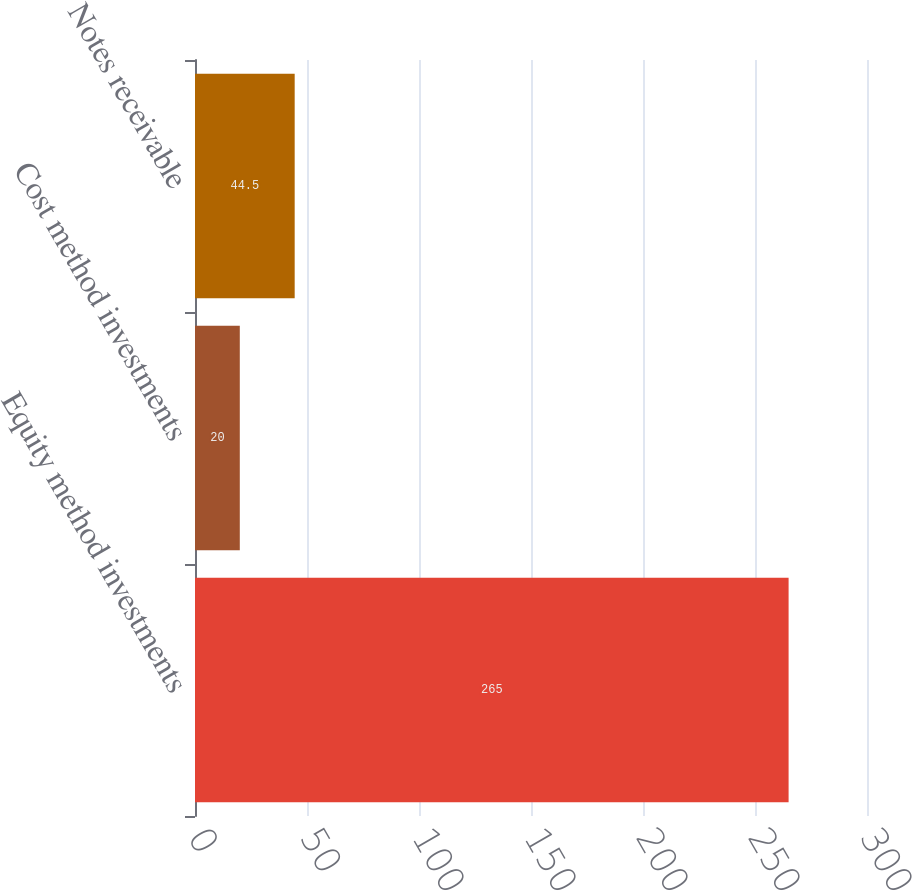Convert chart. <chart><loc_0><loc_0><loc_500><loc_500><bar_chart><fcel>Equity method investments<fcel>Cost method investments<fcel>Notes receivable<nl><fcel>265<fcel>20<fcel>44.5<nl></chart> 